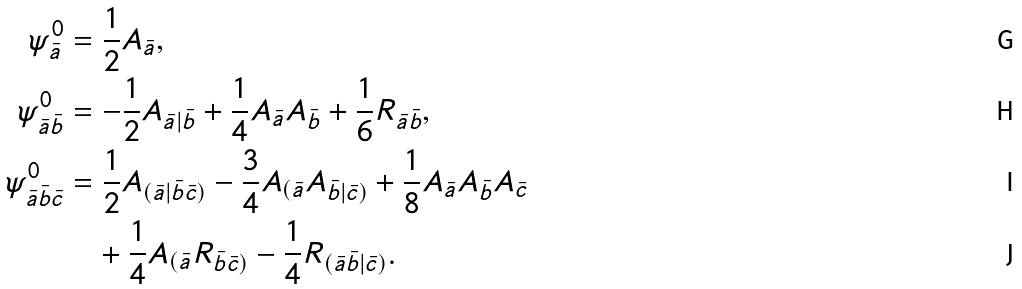Convert formula to latex. <formula><loc_0><loc_0><loc_500><loc_500>\psi ^ { 0 } _ { \bar { a } } & = \frac { 1 } { 2 } A _ { \bar { a } } , \\ \psi ^ { 0 } _ { \bar { a } \bar { b } } & = - \frac { 1 } { 2 } A _ { \bar { a } | \bar { b } } + \frac { 1 } { 4 } A _ { \bar { a } } A _ { \bar { b } } + \frac { 1 } { 6 } R _ { \bar { a } \bar { b } } , \\ \psi ^ { 0 } _ { \bar { a } \bar { b } \bar { c } } & = \frac { 1 } { 2 } A _ { ( \bar { a } | \bar { b } \bar { c } ) } - \frac { 3 } { 4 } A _ { ( \bar { a } } A _ { \bar { b } | \bar { c } ) } + \frac { 1 } { 8 } A _ { \bar { a } } A _ { \bar { b } } A _ { \bar { c } } \\ & \quad + \frac { 1 } { 4 } A _ { ( \bar { a } } R _ { \bar { b } \bar { c } ) } - \frac { 1 } { 4 } R _ { ( \bar { a } \bar { b } | \bar { c } ) } .</formula> 